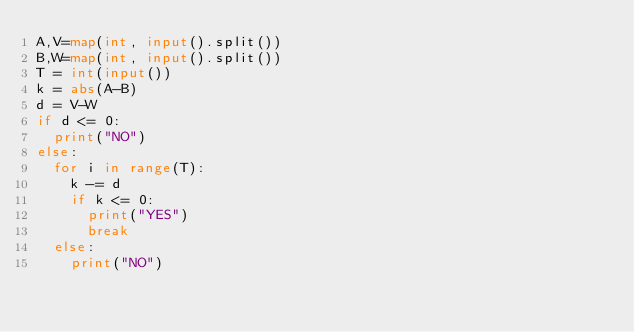Convert code to text. <code><loc_0><loc_0><loc_500><loc_500><_Python_>A,V=map(int, input().split())
B,W=map(int, input().split())
T = int(input())
k = abs(A-B)
d = V-W
if d <= 0:
  print("NO")
else:
  for i in range(T):
    k -= d
    if k <= 0:
      print("YES")
      break
  else:
    print("NO")
</code> 